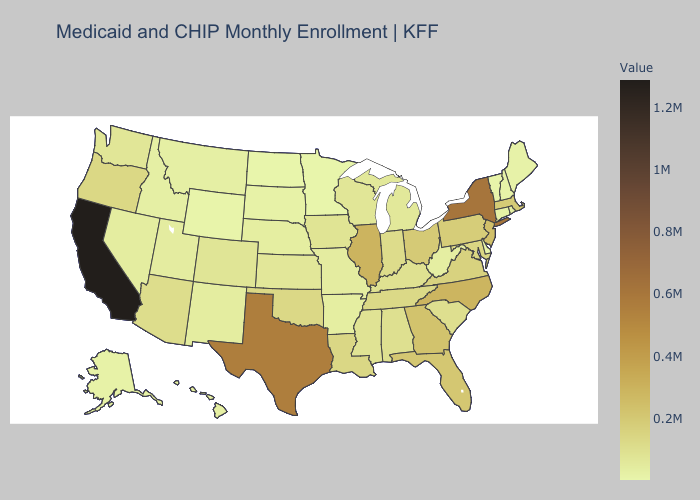Which states have the lowest value in the USA?
Write a very short answer. Minnesota. Among the states that border South Dakota , does Wyoming have the lowest value?
Quick response, please. No. Among the states that border Tennessee , which have the lowest value?
Keep it brief. Arkansas. Does New Hampshire have the highest value in the Northeast?
Be succinct. No. Which states hav the highest value in the South?
Give a very brief answer. Texas. Does California have the highest value in the USA?
Keep it brief. Yes. Does Delaware have the lowest value in the South?
Quick response, please. Yes. Among the states that border Florida , does Alabama have the lowest value?
Give a very brief answer. Yes. Which states hav the highest value in the Northeast?
Concise answer only. New York. 